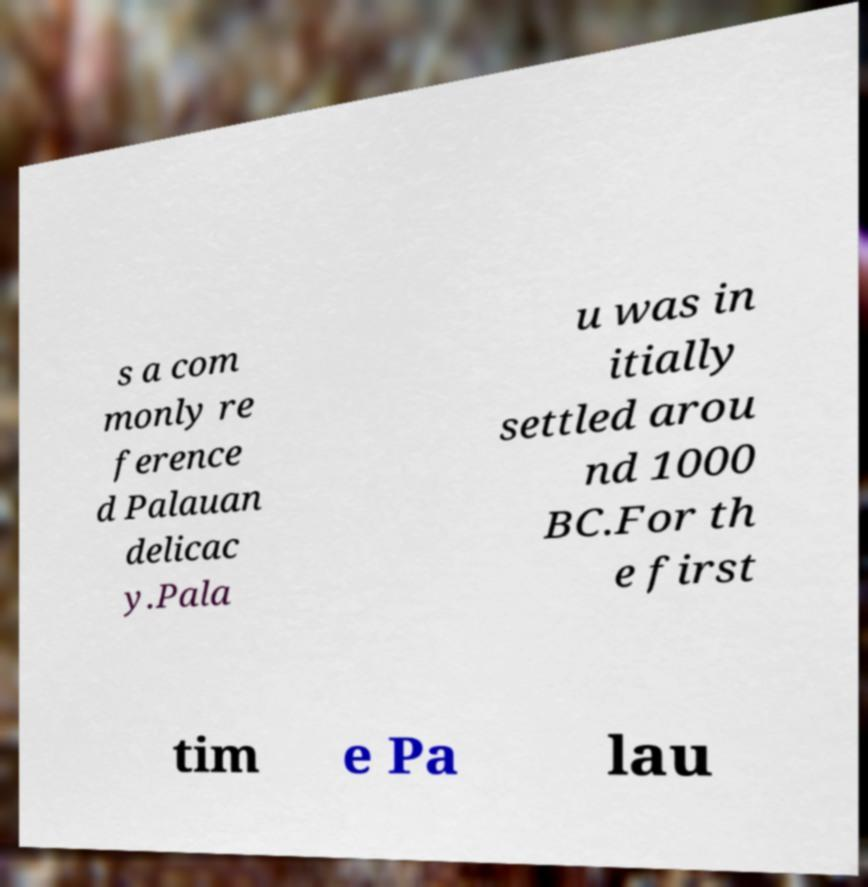Please read and relay the text visible in this image. What does it say? s a com monly re ference d Palauan delicac y.Pala u was in itially settled arou nd 1000 BC.For th e first tim e Pa lau 